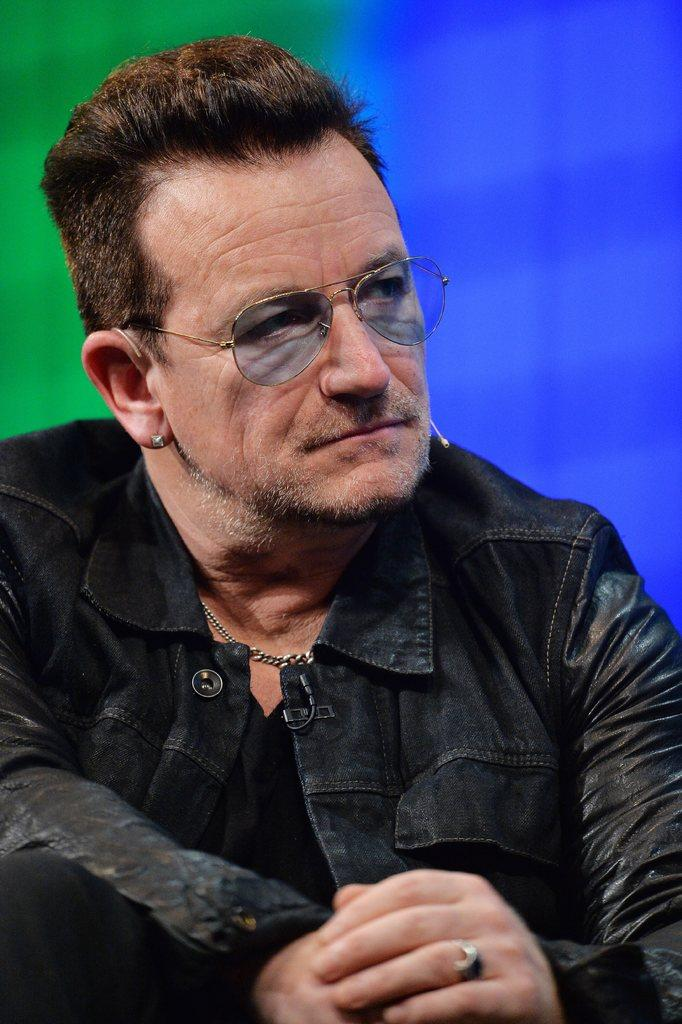Who is present in the image? There is a man in the picture. What is the man wearing on his upper body? The man is wearing a black coat. What type of eyewear is the man wearing? The man is wearing goggles. What type of stove can be seen in the background of the image? There is no stove present in the image. What level of the building is the man standing on in the image? The image does not provide information about the level or floor the man is on. 